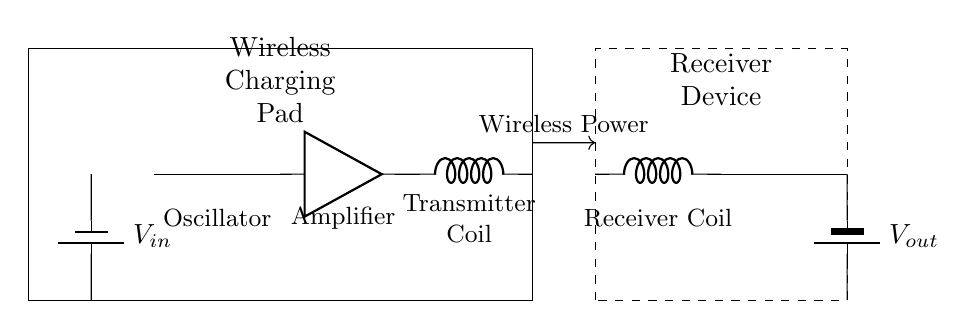What is the purpose of the oscillator in this circuit? The oscillator generates alternating current (AC) for the wireless power transfer process. It is crucial for creating the oscillating electromagnetic field that facilitates energy transfer between the transmitter and receiver coils.
Answer: Generate AC What type of coil is shown at the transmitter end? The component at the transmitter end is an inductor, which is referred to as the transmitter coil. Its primary function is to convert the AC signal produced by the oscillator into an electromagnetic field for wireless charging.
Answer: Transmitter coil Where does the power input come from in this circuit? The power input is provided by the battery labeled V sub in, which supplies the necessary voltage to the entire circuit. The connections indicate that V sub in is the source of energy for components like the oscillator and amplifier.
Answer: V sub in What component is responsible for converting AC back to DC at the receiver? The four-port component labeled as the Rectifier is responsible for this conversion. It transforms the alternating current received by the receiver coil back into direct current to charge the battery.
Answer: Rectifier How does wireless power transfer occur in this circuit? Wireless power transfer occurs through the interaction of the electromagnetic fields generated by the transmitter coil and captured by the receiver coil. The circuit design ensures that the power produced at the transmitter can be transferred without direct physical connections.
Answer: Through electromagnetic fields What type of component limits the current in the wireless charging pad circuit? The amplifier amplifies the input signal but also helps regulate the amount of current flowing through the circuit, ensuring it stays within safe operational limits. It plays a key role in enabling the appropriate power level for efficient charging.
Answer: Amplifier 